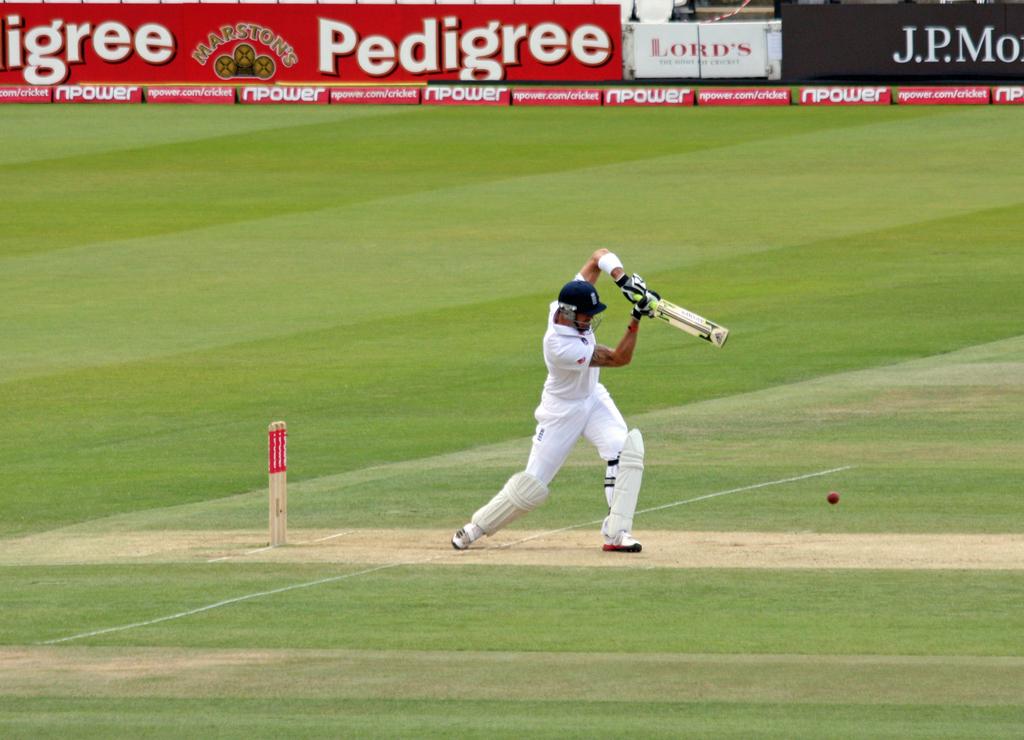What finance company is advertising on the back wall?
Your answer should be compact. J.p. morgan. Who is on the red sign?
Your response must be concise. Pedigree. 